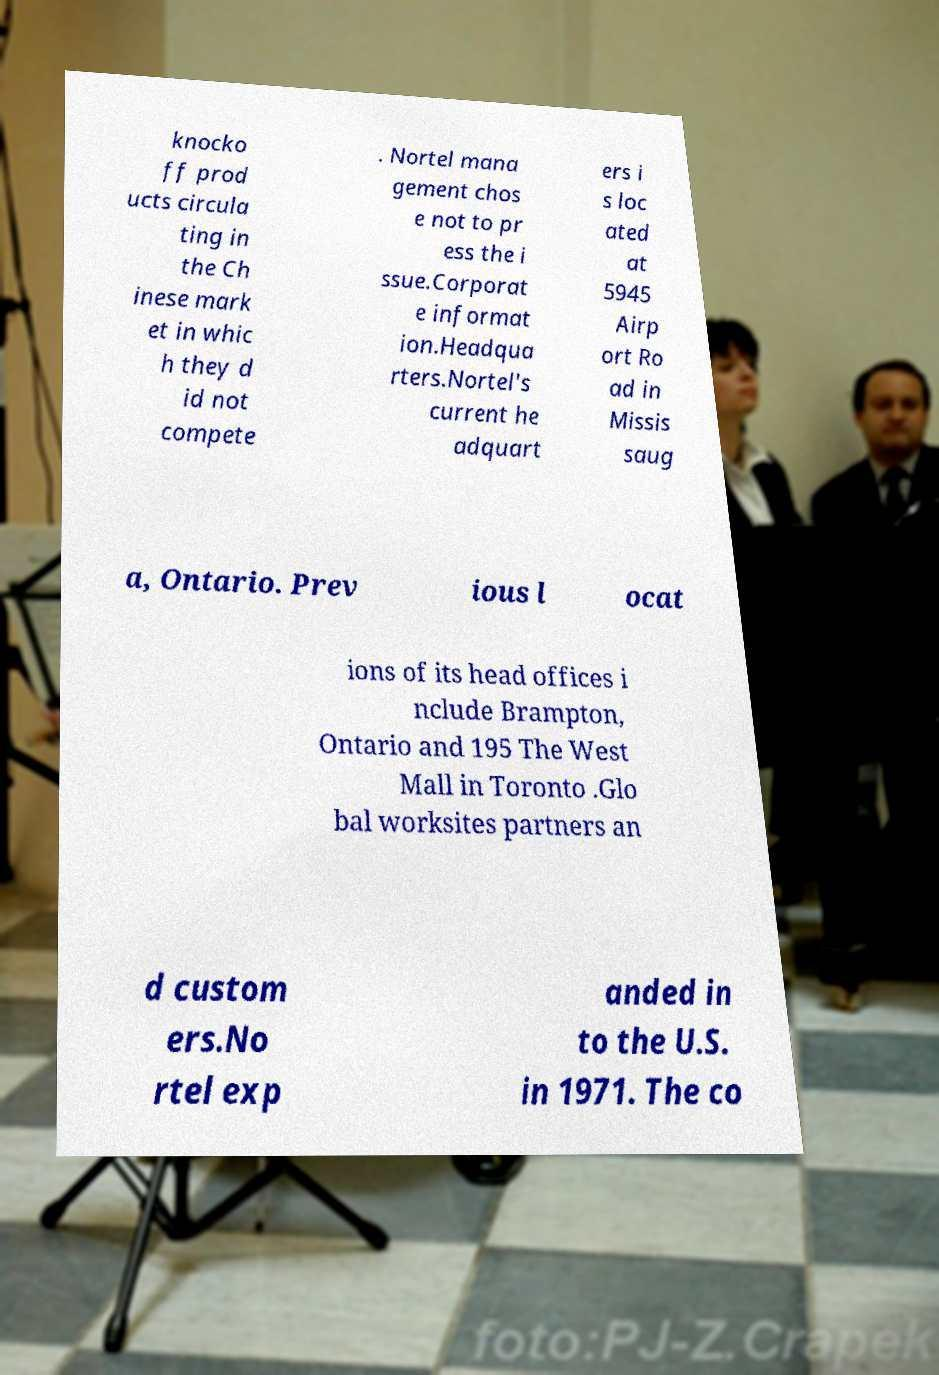There's text embedded in this image that I need extracted. Can you transcribe it verbatim? knocko ff prod ucts circula ting in the Ch inese mark et in whic h they d id not compete . Nortel mana gement chos e not to pr ess the i ssue.Corporat e informat ion.Headqua rters.Nortel's current he adquart ers i s loc ated at 5945 Airp ort Ro ad in Missis saug a, Ontario. Prev ious l ocat ions of its head offices i nclude Brampton, Ontario and 195 The West Mall in Toronto .Glo bal worksites partners an d custom ers.No rtel exp anded in to the U.S. in 1971. The co 